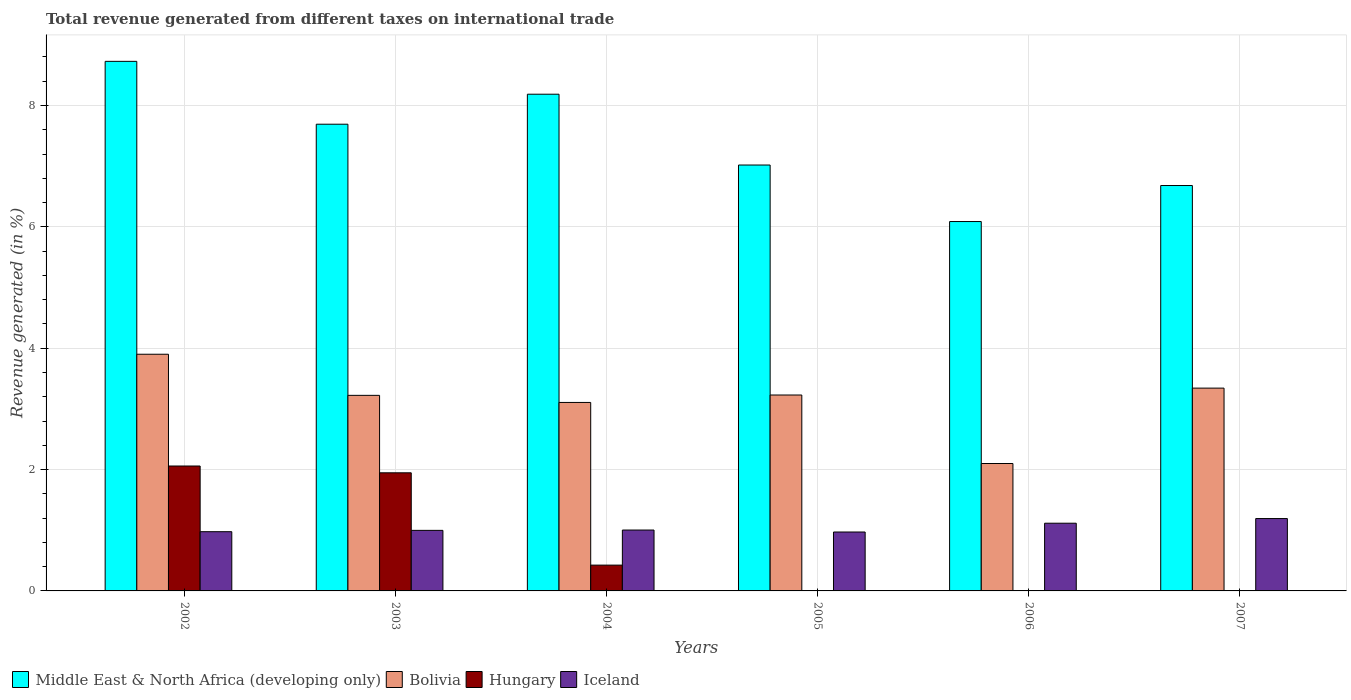How many different coloured bars are there?
Offer a very short reply. 4. Are the number of bars per tick equal to the number of legend labels?
Keep it short and to the point. No. Are the number of bars on each tick of the X-axis equal?
Make the answer very short. No. How many bars are there on the 2nd tick from the right?
Give a very brief answer. 3. What is the label of the 5th group of bars from the left?
Make the answer very short. 2006. What is the total revenue generated in Bolivia in 2004?
Your response must be concise. 3.11. Across all years, what is the maximum total revenue generated in Middle East & North Africa (developing only)?
Ensure brevity in your answer.  8.73. Across all years, what is the minimum total revenue generated in Middle East & North Africa (developing only)?
Provide a short and direct response. 6.09. What is the total total revenue generated in Middle East & North Africa (developing only) in the graph?
Ensure brevity in your answer.  44.39. What is the difference between the total revenue generated in Iceland in 2002 and that in 2004?
Provide a short and direct response. -0.03. What is the difference between the total revenue generated in Hungary in 2005 and the total revenue generated in Iceland in 2002?
Provide a succinct answer. -0.98. What is the average total revenue generated in Hungary per year?
Offer a terse response. 0.74. In the year 2003, what is the difference between the total revenue generated in Bolivia and total revenue generated in Middle East & North Africa (developing only)?
Your response must be concise. -4.47. What is the ratio of the total revenue generated in Iceland in 2003 to that in 2006?
Your answer should be very brief. 0.89. Is the total revenue generated in Middle East & North Africa (developing only) in 2003 less than that in 2005?
Provide a short and direct response. No. Is the difference between the total revenue generated in Bolivia in 2003 and 2005 greater than the difference between the total revenue generated in Middle East & North Africa (developing only) in 2003 and 2005?
Make the answer very short. No. What is the difference between the highest and the second highest total revenue generated in Hungary?
Offer a terse response. 0.11. What is the difference between the highest and the lowest total revenue generated in Middle East & North Africa (developing only)?
Your answer should be very brief. 2.64. In how many years, is the total revenue generated in Hungary greater than the average total revenue generated in Hungary taken over all years?
Provide a short and direct response. 2. Is the sum of the total revenue generated in Iceland in 2004 and 2005 greater than the maximum total revenue generated in Bolivia across all years?
Your answer should be compact. No. Is it the case that in every year, the sum of the total revenue generated in Middle East & North Africa (developing only) and total revenue generated in Bolivia is greater than the sum of total revenue generated in Hungary and total revenue generated in Iceland?
Give a very brief answer. No. Is it the case that in every year, the sum of the total revenue generated in Bolivia and total revenue generated in Middle East & North Africa (developing only) is greater than the total revenue generated in Iceland?
Your answer should be compact. Yes. Are all the bars in the graph horizontal?
Ensure brevity in your answer.  No. What is the difference between two consecutive major ticks on the Y-axis?
Your response must be concise. 2. Does the graph contain any zero values?
Your answer should be very brief. Yes. Does the graph contain grids?
Ensure brevity in your answer.  Yes. How many legend labels are there?
Keep it short and to the point. 4. What is the title of the graph?
Offer a terse response. Total revenue generated from different taxes on international trade. What is the label or title of the Y-axis?
Give a very brief answer. Revenue generated (in %). What is the Revenue generated (in %) in Middle East & North Africa (developing only) in 2002?
Give a very brief answer. 8.73. What is the Revenue generated (in %) of Bolivia in 2002?
Provide a short and direct response. 3.9. What is the Revenue generated (in %) in Hungary in 2002?
Offer a very short reply. 2.06. What is the Revenue generated (in %) in Iceland in 2002?
Provide a succinct answer. 0.98. What is the Revenue generated (in %) in Middle East & North Africa (developing only) in 2003?
Provide a short and direct response. 7.69. What is the Revenue generated (in %) in Bolivia in 2003?
Your response must be concise. 3.22. What is the Revenue generated (in %) in Hungary in 2003?
Your answer should be very brief. 1.95. What is the Revenue generated (in %) of Iceland in 2003?
Ensure brevity in your answer.  1. What is the Revenue generated (in %) in Middle East & North Africa (developing only) in 2004?
Make the answer very short. 8.19. What is the Revenue generated (in %) of Bolivia in 2004?
Provide a short and direct response. 3.11. What is the Revenue generated (in %) of Hungary in 2004?
Your answer should be very brief. 0.43. What is the Revenue generated (in %) of Iceland in 2004?
Offer a very short reply. 1. What is the Revenue generated (in %) of Middle East & North Africa (developing only) in 2005?
Your answer should be very brief. 7.02. What is the Revenue generated (in %) in Bolivia in 2005?
Offer a very short reply. 3.23. What is the Revenue generated (in %) of Iceland in 2005?
Ensure brevity in your answer.  0.97. What is the Revenue generated (in %) in Middle East & North Africa (developing only) in 2006?
Provide a succinct answer. 6.09. What is the Revenue generated (in %) in Bolivia in 2006?
Make the answer very short. 2.1. What is the Revenue generated (in %) of Iceland in 2006?
Keep it short and to the point. 1.12. What is the Revenue generated (in %) in Middle East & North Africa (developing only) in 2007?
Provide a short and direct response. 6.68. What is the Revenue generated (in %) in Bolivia in 2007?
Your response must be concise. 3.34. What is the Revenue generated (in %) in Hungary in 2007?
Offer a very short reply. 0. What is the Revenue generated (in %) of Iceland in 2007?
Your answer should be compact. 1.19. Across all years, what is the maximum Revenue generated (in %) of Middle East & North Africa (developing only)?
Provide a short and direct response. 8.73. Across all years, what is the maximum Revenue generated (in %) of Bolivia?
Provide a short and direct response. 3.9. Across all years, what is the maximum Revenue generated (in %) in Hungary?
Offer a very short reply. 2.06. Across all years, what is the maximum Revenue generated (in %) in Iceland?
Keep it short and to the point. 1.19. Across all years, what is the minimum Revenue generated (in %) in Middle East & North Africa (developing only)?
Make the answer very short. 6.09. Across all years, what is the minimum Revenue generated (in %) in Bolivia?
Give a very brief answer. 2.1. Across all years, what is the minimum Revenue generated (in %) in Iceland?
Keep it short and to the point. 0.97. What is the total Revenue generated (in %) of Middle East & North Africa (developing only) in the graph?
Provide a succinct answer. 44.39. What is the total Revenue generated (in %) in Bolivia in the graph?
Provide a succinct answer. 18.9. What is the total Revenue generated (in %) of Hungary in the graph?
Your answer should be very brief. 4.43. What is the total Revenue generated (in %) of Iceland in the graph?
Offer a terse response. 6.26. What is the difference between the Revenue generated (in %) in Middle East & North Africa (developing only) in 2002 and that in 2003?
Your answer should be very brief. 1.04. What is the difference between the Revenue generated (in %) of Bolivia in 2002 and that in 2003?
Your response must be concise. 0.68. What is the difference between the Revenue generated (in %) of Hungary in 2002 and that in 2003?
Give a very brief answer. 0.11. What is the difference between the Revenue generated (in %) of Iceland in 2002 and that in 2003?
Offer a very short reply. -0.02. What is the difference between the Revenue generated (in %) in Middle East & North Africa (developing only) in 2002 and that in 2004?
Your response must be concise. 0.54. What is the difference between the Revenue generated (in %) in Bolivia in 2002 and that in 2004?
Provide a short and direct response. 0.79. What is the difference between the Revenue generated (in %) of Hungary in 2002 and that in 2004?
Offer a terse response. 1.63. What is the difference between the Revenue generated (in %) of Iceland in 2002 and that in 2004?
Provide a succinct answer. -0.03. What is the difference between the Revenue generated (in %) of Middle East & North Africa (developing only) in 2002 and that in 2005?
Provide a succinct answer. 1.71. What is the difference between the Revenue generated (in %) of Bolivia in 2002 and that in 2005?
Keep it short and to the point. 0.67. What is the difference between the Revenue generated (in %) in Iceland in 2002 and that in 2005?
Your answer should be very brief. 0.01. What is the difference between the Revenue generated (in %) of Middle East & North Africa (developing only) in 2002 and that in 2006?
Offer a terse response. 2.64. What is the difference between the Revenue generated (in %) of Bolivia in 2002 and that in 2006?
Provide a short and direct response. 1.8. What is the difference between the Revenue generated (in %) in Iceland in 2002 and that in 2006?
Provide a succinct answer. -0.14. What is the difference between the Revenue generated (in %) of Middle East & North Africa (developing only) in 2002 and that in 2007?
Your answer should be compact. 2.05. What is the difference between the Revenue generated (in %) in Bolivia in 2002 and that in 2007?
Give a very brief answer. 0.56. What is the difference between the Revenue generated (in %) of Iceland in 2002 and that in 2007?
Provide a short and direct response. -0.22. What is the difference between the Revenue generated (in %) of Middle East & North Africa (developing only) in 2003 and that in 2004?
Your response must be concise. -0.49. What is the difference between the Revenue generated (in %) in Bolivia in 2003 and that in 2004?
Make the answer very short. 0.12. What is the difference between the Revenue generated (in %) of Hungary in 2003 and that in 2004?
Keep it short and to the point. 1.52. What is the difference between the Revenue generated (in %) of Iceland in 2003 and that in 2004?
Provide a short and direct response. -0.01. What is the difference between the Revenue generated (in %) of Middle East & North Africa (developing only) in 2003 and that in 2005?
Offer a terse response. 0.67. What is the difference between the Revenue generated (in %) of Bolivia in 2003 and that in 2005?
Offer a terse response. -0.01. What is the difference between the Revenue generated (in %) of Iceland in 2003 and that in 2005?
Offer a terse response. 0.03. What is the difference between the Revenue generated (in %) of Middle East & North Africa (developing only) in 2003 and that in 2006?
Keep it short and to the point. 1.6. What is the difference between the Revenue generated (in %) in Bolivia in 2003 and that in 2006?
Offer a very short reply. 1.12. What is the difference between the Revenue generated (in %) of Iceland in 2003 and that in 2006?
Ensure brevity in your answer.  -0.12. What is the difference between the Revenue generated (in %) of Middle East & North Africa (developing only) in 2003 and that in 2007?
Make the answer very short. 1.01. What is the difference between the Revenue generated (in %) in Bolivia in 2003 and that in 2007?
Your answer should be compact. -0.12. What is the difference between the Revenue generated (in %) in Iceland in 2003 and that in 2007?
Provide a short and direct response. -0.19. What is the difference between the Revenue generated (in %) in Middle East & North Africa (developing only) in 2004 and that in 2005?
Your answer should be very brief. 1.17. What is the difference between the Revenue generated (in %) of Bolivia in 2004 and that in 2005?
Keep it short and to the point. -0.12. What is the difference between the Revenue generated (in %) in Iceland in 2004 and that in 2005?
Provide a succinct answer. 0.03. What is the difference between the Revenue generated (in %) of Middle East & North Africa (developing only) in 2004 and that in 2006?
Your answer should be very brief. 2.1. What is the difference between the Revenue generated (in %) in Bolivia in 2004 and that in 2006?
Offer a very short reply. 1.01. What is the difference between the Revenue generated (in %) of Iceland in 2004 and that in 2006?
Provide a short and direct response. -0.11. What is the difference between the Revenue generated (in %) in Middle East & North Africa (developing only) in 2004 and that in 2007?
Make the answer very short. 1.5. What is the difference between the Revenue generated (in %) in Bolivia in 2004 and that in 2007?
Give a very brief answer. -0.24. What is the difference between the Revenue generated (in %) in Iceland in 2004 and that in 2007?
Your answer should be very brief. -0.19. What is the difference between the Revenue generated (in %) of Middle East & North Africa (developing only) in 2005 and that in 2006?
Offer a terse response. 0.93. What is the difference between the Revenue generated (in %) of Bolivia in 2005 and that in 2006?
Give a very brief answer. 1.13. What is the difference between the Revenue generated (in %) of Iceland in 2005 and that in 2006?
Ensure brevity in your answer.  -0.14. What is the difference between the Revenue generated (in %) in Middle East & North Africa (developing only) in 2005 and that in 2007?
Give a very brief answer. 0.34. What is the difference between the Revenue generated (in %) of Bolivia in 2005 and that in 2007?
Make the answer very short. -0.11. What is the difference between the Revenue generated (in %) in Iceland in 2005 and that in 2007?
Your answer should be compact. -0.22. What is the difference between the Revenue generated (in %) in Middle East & North Africa (developing only) in 2006 and that in 2007?
Your answer should be compact. -0.59. What is the difference between the Revenue generated (in %) of Bolivia in 2006 and that in 2007?
Offer a terse response. -1.24. What is the difference between the Revenue generated (in %) in Iceland in 2006 and that in 2007?
Offer a very short reply. -0.08. What is the difference between the Revenue generated (in %) in Middle East & North Africa (developing only) in 2002 and the Revenue generated (in %) in Bolivia in 2003?
Offer a terse response. 5.5. What is the difference between the Revenue generated (in %) in Middle East & North Africa (developing only) in 2002 and the Revenue generated (in %) in Hungary in 2003?
Your response must be concise. 6.78. What is the difference between the Revenue generated (in %) of Middle East & North Africa (developing only) in 2002 and the Revenue generated (in %) of Iceland in 2003?
Offer a very short reply. 7.73. What is the difference between the Revenue generated (in %) of Bolivia in 2002 and the Revenue generated (in %) of Hungary in 2003?
Ensure brevity in your answer.  1.95. What is the difference between the Revenue generated (in %) in Bolivia in 2002 and the Revenue generated (in %) in Iceland in 2003?
Your answer should be very brief. 2.9. What is the difference between the Revenue generated (in %) in Hungary in 2002 and the Revenue generated (in %) in Iceland in 2003?
Your answer should be very brief. 1.06. What is the difference between the Revenue generated (in %) of Middle East & North Africa (developing only) in 2002 and the Revenue generated (in %) of Bolivia in 2004?
Keep it short and to the point. 5.62. What is the difference between the Revenue generated (in %) in Middle East & North Africa (developing only) in 2002 and the Revenue generated (in %) in Hungary in 2004?
Provide a short and direct response. 8.3. What is the difference between the Revenue generated (in %) in Middle East & North Africa (developing only) in 2002 and the Revenue generated (in %) in Iceland in 2004?
Make the answer very short. 7.72. What is the difference between the Revenue generated (in %) in Bolivia in 2002 and the Revenue generated (in %) in Hungary in 2004?
Provide a short and direct response. 3.48. What is the difference between the Revenue generated (in %) of Bolivia in 2002 and the Revenue generated (in %) of Iceland in 2004?
Your answer should be very brief. 2.9. What is the difference between the Revenue generated (in %) in Hungary in 2002 and the Revenue generated (in %) in Iceland in 2004?
Give a very brief answer. 1.06. What is the difference between the Revenue generated (in %) of Middle East & North Africa (developing only) in 2002 and the Revenue generated (in %) of Bolivia in 2005?
Provide a succinct answer. 5.5. What is the difference between the Revenue generated (in %) in Middle East & North Africa (developing only) in 2002 and the Revenue generated (in %) in Iceland in 2005?
Keep it short and to the point. 7.76. What is the difference between the Revenue generated (in %) in Bolivia in 2002 and the Revenue generated (in %) in Iceland in 2005?
Give a very brief answer. 2.93. What is the difference between the Revenue generated (in %) of Hungary in 2002 and the Revenue generated (in %) of Iceland in 2005?
Ensure brevity in your answer.  1.09. What is the difference between the Revenue generated (in %) in Middle East & North Africa (developing only) in 2002 and the Revenue generated (in %) in Bolivia in 2006?
Your answer should be very brief. 6.63. What is the difference between the Revenue generated (in %) in Middle East & North Africa (developing only) in 2002 and the Revenue generated (in %) in Iceland in 2006?
Your answer should be compact. 7.61. What is the difference between the Revenue generated (in %) in Bolivia in 2002 and the Revenue generated (in %) in Iceland in 2006?
Your answer should be very brief. 2.78. What is the difference between the Revenue generated (in %) in Hungary in 2002 and the Revenue generated (in %) in Iceland in 2006?
Keep it short and to the point. 0.94. What is the difference between the Revenue generated (in %) in Middle East & North Africa (developing only) in 2002 and the Revenue generated (in %) in Bolivia in 2007?
Keep it short and to the point. 5.39. What is the difference between the Revenue generated (in %) in Middle East & North Africa (developing only) in 2002 and the Revenue generated (in %) in Iceland in 2007?
Ensure brevity in your answer.  7.53. What is the difference between the Revenue generated (in %) in Bolivia in 2002 and the Revenue generated (in %) in Iceland in 2007?
Your response must be concise. 2.71. What is the difference between the Revenue generated (in %) in Hungary in 2002 and the Revenue generated (in %) in Iceland in 2007?
Offer a very short reply. 0.87. What is the difference between the Revenue generated (in %) of Middle East & North Africa (developing only) in 2003 and the Revenue generated (in %) of Bolivia in 2004?
Provide a succinct answer. 4.59. What is the difference between the Revenue generated (in %) in Middle East & North Africa (developing only) in 2003 and the Revenue generated (in %) in Hungary in 2004?
Your answer should be very brief. 7.27. What is the difference between the Revenue generated (in %) of Middle East & North Africa (developing only) in 2003 and the Revenue generated (in %) of Iceland in 2004?
Ensure brevity in your answer.  6.69. What is the difference between the Revenue generated (in %) in Bolivia in 2003 and the Revenue generated (in %) in Hungary in 2004?
Offer a terse response. 2.8. What is the difference between the Revenue generated (in %) in Bolivia in 2003 and the Revenue generated (in %) in Iceland in 2004?
Keep it short and to the point. 2.22. What is the difference between the Revenue generated (in %) of Hungary in 2003 and the Revenue generated (in %) of Iceland in 2004?
Your answer should be compact. 0.94. What is the difference between the Revenue generated (in %) of Middle East & North Africa (developing only) in 2003 and the Revenue generated (in %) of Bolivia in 2005?
Provide a succinct answer. 4.46. What is the difference between the Revenue generated (in %) in Middle East & North Africa (developing only) in 2003 and the Revenue generated (in %) in Iceland in 2005?
Your answer should be very brief. 6.72. What is the difference between the Revenue generated (in %) in Bolivia in 2003 and the Revenue generated (in %) in Iceland in 2005?
Keep it short and to the point. 2.25. What is the difference between the Revenue generated (in %) in Hungary in 2003 and the Revenue generated (in %) in Iceland in 2005?
Give a very brief answer. 0.98. What is the difference between the Revenue generated (in %) in Middle East & North Africa (developing only) in 2003 and the Revenue generated (in %) in Bolivia in 2006?
Provide a short and direct response. 5.59. What is the difference between the Revenue generated (in %) of Middle East & North Africa (developing only) in 2003 and the Revenue generated (in %) of Iceland in 2006?
Give a very brief answer. 6.58. What is the difference between the Revenue generated (in %) of Bolivia in 2003 and the Revenue generated (in %) of Iceland in 2006?
Ensure brevity in your answer.  2.11. What is the difference between the Revenue generated (in %) in Hungary in 2003 and the Revenue generated (in %) in Iceland in 2006?
Offer a very short reply. 0.83. What is the difference between the Revenue generated (in %) of Middle East & North Africa (developing only) in 2003 and the Revenue generated (in %) of Bolivia in 2007?
Provide a succinct answer. 4.35. What is the difference between the Revenue generated (in %) in Middle East & North Africa (developing only) in 2003 and the Revenue generated (in %) in Iceland in 2007?
Your answer should be compact. 6.5. What is the difference between the Revenue generated (in %) in Bolivia in 2003 and the Revenue generated (in %) in Iceland in 2007?
Your answer should be very brief. 2.03. What is the difference between the Revenue generated (in %) of Hungary in 2003 and the Revenue generated (in %) of Iceland in 2007?
Make the answer very short. 0.75. What is the difference between the Revenue generated (in %) in Middle East & North Africa (developing only) in 2004 and the Revenue generated (in %) in Bolivia in 2005?
Make the answer very short. 4.96. What is the difference between the Revenue generated (in %) of Middle East & North Africa (developing only) in 2004 and the Revenue generated (in %) of Iceland in 2005?
Offer a terse response. 7.22. What is the difference between the Revenue generated (in %) in Bolivia in 2004 and the Revenue generated (in %) in Iceland in 2005?
Give a very brief answer. 2.14. What is the difference between the Revenue generated (in %) in Hungary in 2004 and the Revenue generated (in %) in Iceland in 2005?
Provide a short and direct response. -0.55. What is the difference between the Revenue generated (in %) of Middle East & North Africa (developing only) in 2004 and the Revenue generated (in %) of Bolivia in 2006?
Offer a terse response. 6.09. What is the difference between the Revenue generated (in %) of Middle East & North Africa (developing only) in 2004 and the Revenue generated (in %) of Iceland in 2006?
Offer a terse response. 7.07. What is the difference between the Revenue generated (in %) of Bolivia in 2004 and the Revenue generated (in %) of Iceland in 2006?
Offer a very short reply. 1.99. What is the difference between the Revenue generated (in %) in Hungary in 2004 and the Revenue generated (in %) in Iceland in 2006?
Provide a succinct answer. -0.69. What is the difference between the Revenue generated (in %) of Middle East & North Africa (developing only) in 2004 and the Revenue generated (in %) of Bolivia in 2007?
Keep it short and to the point. 4.84. What is the difference between the Revenue generated (in %) of Middle East & North Africa (developing only) in 2004 and the Revenue generated (in %) of Iceland in 2007?
Make the answer very short. 6.99. What is the difference between the Revenue generated (in %) of Bolivia in 2004 and the Revenue generated (in %) of Iceland in 2007?
Your answer should be compact. 1.91. What is the difference between the Revenue generated (in %) of Hungary in 2004 and the Revenue generated (in %) of Iceland in 2007?
Keep it short and to the point. -0.77. What is the difference between the Revenue generated (in %) of Middle East & North Africa (developing only) in 2005 and the Revenue generated (in %) of Bolivia in 2006?
Provide a short and direct response. 4.92. What is the difference between the Revenue generated (in %) of Middle East & North Africa (developing only) in 2005 and the Revenue generated (in %) of Iceland in 2006?
Your answer should be very brief. 5.9. What is the difference between the Revenue generated (in %) in Bolivia in 2005 and the Revenue generated (in %) in Iceland in 2006?
Your answer should be compact. 2.11. What is the difference between the Revenue generated (in %) of Middle East & North Africa (developing only) in 2005 and the Revenue generated (in %) of Bolivia in 2007?
Offer a terse response. 3.68. What is the difference between the Revenue generated (in %) of Middle East & North Africa (developing only) in 2005 and the Revenue generated (in %) of Iceland in 2007?
Give a very brief answer. 5.83. What is the difference between the Revenue generated (in %) in Bolivia in 2005 and the Revenue generated (in %) in Iceland in 2007?
Your answer should be very brief. 2.04. What is the difference between the Revenue generated (in %) in Middle East & North Africa (developing only) in 2006 and the Revenue generated (in %) in Bolivia in 2007?
Your answer should be very brief. 2.75. What is the difference between the Revenue generated (in %) in Middle East & North Africa (developing only) in 2006 and the Revenue generated (in %) in Iceland in 2007?
Provide a short and direct response. 4.89. What is the difference between the Revenue generated (in %) in Bolivia in 2006 and the Revenue generated (in %) in Iceland in 2007?
Ensure brevity in your answer.  0.91. What is the average Revenue generated (in %) in Middle East & North Africa (developing only) per year?
Offer a terse response. 7.4. What is the average Revenue generated (in %) in Bolivia per year?
Your answer should be compact. 3.15. What is the average Revenue generated (in %) of Hungary per year?
Make the answer very short. 0.74. What is the average Revenue generated (in %) in Iceland per year?
Provide a short and direct response. 1.04. In the year 2002, what is the difference between the Revenue generated (in %) in Middle East & North Africa (developing only) and Revenue generated (in %) in Bolivia?
Make the answer very short. 4.83. In the year 2002, what is the difference between the Revenue generated (in %) in Middle East & North Africa (developing only) and Revenue generated (in %) in Hungary?
Ensure brevity in your answer.  6.67. In the year 2002, what is the difference between the Revenue generated (in %) of Middle East & North Africa (developing only) and Revenue generated (in %) of Iceland?
Your answer should be compact. 7.75. In the year 2002, what is the difference between the Revenue generated (in %) in Bolivia and Revenue generated (in %) in Hungary?
Keep it short and to the point. 1.84. In the year 2002, what is the difference between the Revenue generated (in %) in Bolivia and Revenue generated (in %) in Iceland?
Your answer should be compact. 2.92. In the year 2002, what is the difference between the Revenue generated (in %) in Hungary and Revenue generated (in %) in Iceland?
Provide a succinct answer. 1.08. In the year 2003, what is the difference between the Revenue generated (in %) in Middle East & North Africa (developing only) and Revenue generated (in %) in Bolivia?
Your answer should be compact. 4.47. In the year 2003, what is the difference between the Revenue generated (in %) of Middle East & North Africa (developing only) and Revenue generated (in %) of Hungary?
Provide a succinct answer. 5.75. In the year 2003, what is the difference between the Revenue generated (in %) in Middle East & North Africa (developing only) and Revenue generated (in %) in Iceland?
Your answer should be very brief. 6.69. In the year 2003, what is the difference between the Revenue generated (in %) of Bolivia and Revenue generated (in %) of Hungary?
Provide a succinct answer. 1.28. In the year 2003, what is the difference between the Revenue generated (in %) in Bolivia and Revenue generated (in %) in Iceland?
Offer a very short reply. 2.23. In the year 2003, what is the difference between the Revenue generated (in %) of Hungary and Revenue generated (in %) of Iceland?
Make the answer very short. 0.95. In the year 2004, what is the difference between the Revenue generated (in %) of Middle East & North Africa (developing only) and Revenue generated (in %) of Bolivia?
Your answer should be compact. 5.08. In the year 2004, what is the difference between the Revenue generated (in %) of Middle East & North Africa (developing only) and Revenue generated (in %) of Hungary?
Provide a short and direct response. 7.76. In the year 2004, what is the difference between the Revenue generated (in %) of Middle East & North Africa (developing only) and Revenue generated (in %) of Iceland?
Offer a very short reply. 7.18. In the year 2004, what is the difference between the Revenue generated (in %) in Bolivia and Revenue generated (in %) in Hungary?
Offer a terse response. 2.68. In the year 2004, what is the difference between the Revenue generated (in %) of Bolivia and Revenue generated (in %) of Iceland?
Your response must be concise. 2.1. In the year 2004, what is the difference between the Revenue generated (in %) in Hungary and Revenue generated (in %) in Iceland?
Provide a short and direct response. -0.58. In the year 2005, what is the difference between the Revenue generated (in %) of Middle East & North Africa (developing only) and Revenue generated (in %) of Bolivia?
Offer a terse response. 3.79. In the year 2005, what is the difference between the Revenue generated (in %) of Middle East & North Africa (developing only) and Revenue generated (in %) of Iceland?
Your answer should be compact. 6.05. In the year 2005, what is the difference between the Revenue generated (in %) in Bolivia and Revenue generated (in %) in Iceland?
Your response must be concise. 2.26. In the year 2006, what is the difference between the Revenue generated (in %) of Middle East & North Africa (developing only) and Revenue generated (in %) of Bolivia?
Give a very brief answer. 3.99. In the year 2006, what is the difference between the Revenue generated (in %) in Middle East & North Africa (developing only) and Revenue generated (in %) in Iceland?
Make the answer very short. 4.97. In the year 2006, what is the difference between the Revenue generated (in %) in Bolivia and Revenue generated (in %) in Iceland?
Make the answer very short. 0.98. In the year 2007, what is the difference between the Revenue generated (in %) in Middle East & North Africa (developing only) and Revenue generated (in %) in Bolivia?
Offer a terse response. 3.34. In the year 2007, what is the difference between the Revenue generated (in %) in Middle East & North Africa (developing only) and Revenue generated (in %) in Iceland?
Make the answer very short. 5.49. In the year 2007, what is the difference between the Revenue generated (in %) in Bolivia and Revenue generated (in %) in Iceland?
Ensure brevity in your answer.  2.15. What is the ratio of the Revenue generated (in %) in Middle East & North Africa (developing only) in 2002 to that in 2003?
Ensure brevity in your answer.  1.13. What is the ratio of the Revenue generated (in %) of Bolivia in 2002 to that in 2003?
Your answer should be compact. 1.21. What is the ratio of the Revenue generated (in %) in Hungary in 2002 to that in 2003?
Offer a very short reply. 1.06. What is the ratio of the Revenue generated (in %) in Iceland in 2002 to that in 2003?
Offer a very short reply. 0.98. What is the ratio of the Revenue generated (in %) of Middle East & North Africa (developing only) in 2002 to that in 2004?
Ensure brevity in your answer.  1.07. What is the ratio of the Revenue generated (in %) in Bolivia in 2002 to that in 2004?
Ensure brevity in your answer.  1.26. What is the ratio of the Revenue generated (in %) of Hungary in 2002 to that in 2004?
Make the answer very short. 4.84. What is the ratio of the Revenue generated (in %) in Iceland in 2002 to that in 2004?
Provide a short and direct response. 0.97. What is the ratio of the Revenue generated (in %) in Middle East & North Africa (developing only) in 2002 to that in 2005?
Make the answer very short. 1.24. What is the ratio of the Revenue generated (in %) of Bolivia in 2002 to that in 2005?
Your answer should be very brief. 1.21. What is the ratio of the Revenue generated (in %) of Iceland in 2002 to that in 2005?
Offer a very short reply. 1.01. What is the ratio of the Revenue generated (in %) of Middle East & North Africa (developing only) in 2002 to that in 2006?
Keep it short and to the point. 1.43. What is the ratio of the Revenue generated (in %) in Bolivia in 2002 to that in 2006?
Make the answer very short. 1.86. What is the ratio of the Revenue generated (in %) of Iceland in 2002 to that in 2006?
Your answer should be very brief. 0.87. What is the ratio of the Revenue generated (in %) in Middle East & North Africa (developing only) in 2002 to that in 2007?
Make the answer very short. 1.31. What is the ratio of the Revenue generated (in %) in Bolivia in 2002 to that in 2007?
Your answer should be very brief. 1.17. What is the ratio of the Revenue generated (in %) of Iceland in 2002 to that in 2007?
Offer a terse response. 0.82. What is the ratio of the Revenue generated (in %) in Middle East & North Africa (developing only) in 2003 to that in 2004?
Offer a very short reply. 0.94. What is the ratio of the Revenue generated (in %) of Bolivia in 2003 to that in 2004?
Offer a terse response. 1.04. What is the ratio of the Revenue generated (in %) in Hungary in 2003 to that in 2004?
Your response must be concise. 4.58. What is the ratio of the Revenue generated (in %) of Iceland in 2003 to that in 2004?
Keep it short and to the point. 0.99. What is the ratio of the Revenue generated (in %) in Middle East & North Africa (developing only) in 2003 to that in 2005?
Offer a very short reply. 1.1. What is the ratio of the Revenue generated (in %) of Iceland in 2003 to that in 2005?
Offer a very short reply. 1.03. What is the ratio of the Revenue generated (in %) in Middle East & North Africa (developing only) in 2003 to that in 2006?
Keep it short and to the point. 1.26. What is the ratio of the Revenue generated (in %) of Bolivia in 2003 to that in 2006?
Your answer should be very brief. 1.53. What is the ratio of the Revenue generated (in %) in Iceland in 2003 to that in 2006?
Your response must be concise. 0.89. What is the ratio of the Revenue generated (in %) of Middle East & North Africa (developing only) in 2003 to that in 2007?
Keep it short and to the point. 1.15. What is the ratio of the Revenue generated (in %) of Bolivia in 2003 to that in 2007?
Ensure brevity in your answer.  0.96. What is the ratio of the Revenue generated (in %) in Iceland in 2003 to that in 2007?
Give a very brief answer. 0.84. What is the ratio of the Revenue generated (in %) of Middle East & North Africa (developing only) in 2004 to that in 2005?
Make the answer very short. 1.17. What is the ratio of the Revenue generated (in %) of Iceland in 2004 to that in 2005?
Ensure brevity in your answer.  1.03. What is the ratio of the Revenue generated (in %) in Middle East & North Africa (developing only) in 2004 to that in 2006?
Your response must be concise. 1.34. What is the ratio of the Revenue generated (in %) in Bolivia in 2004 to that in 2006?
Offer a terse response. 1.48. What is the ratio of the Revenue generated (in %) in Iceland in 2004 to that in 2006?
Provide a succinct answer. 0.9. What is the ratio of the Revenue generated (in %) in Middle East & North Africa (developing only) in 2004 to that in 2007?
Offer a very short reply. 1.23. What is the ratio of the Revenue generated (in %) of Bolivia in 2004 to that in 2007?
Give a very brief answer. 0.93. What is the ratio of the Revenue generated (in %) in Iceland in 2004 to that in 2007?
Ensure brevity in your answer.  0.84. What is the ratio of the Revenue generated (in %) in Middle East & North Africa (developing only) in 2005 to that in 2006?
Your answer should be very brief. 1.15. What is the ratio of the Revenue generated (in %) of Bolivia in 2005 to that in 2006?
Ensure brevity in your answer.  1.54. What is the ratio of the Revenue generated (in %) in Iceland in 2005 to that in 2006?
Make the answer very short. 0.87. What is the ratio of the Revenue generated (in %) in Middle East & North Africa (developing only) in 2005 to that in 2007?
Ensure brevity in your answer.  1.05. What is the ratio of the Revenue generated (in %) of Bolivia in 2005 to that in 2007?
Your answer should be very brief. 0.97. What is the ratio of the Revenue generated (in %) of Iceland in 2005 to that in 2007?
Make the answer very short. 0.81. What is the ratio of the Revenue generated (in %) in Middle East & North Africa (developing only) in 2006 to that in 2007?
Your answer should be compact. 0.91. What is the ratio of the Revenue generated (in %) of Bolivia in 2006 to that in 2007?
Your response must be concise. 0.63. What is the ratio of the Revenue generated (in %) in Iceland in 2006 to that in 2007?
Your answer should be very brief. 0.94. What is the difference between the highest and the second highest Revenue generated (in %) in Middle East & North Africa (developing only)?
Offer a terse response. 0.54. What is the difference between the highest and the second highest Revenue generated (in %) of Bolivia?
Provide a succinct answer. 0.56. What is the difference between the highest and the second highest Revenue generated (in %) in Hungary?
Make the answer very short. 0.11. What is the difference between the highest and the second highest Revenue generated (in %) in Iceland?
Keep it short and to the point. 0.08. What is the difference between the highest and the lowest Revenue generated (in %) of Middle East & North Africa (developing only)?
Offer a very short reply. 2.64. What is the difference between the highest and the lowest Revenue generated (in %) of Bolivia?
Your answer should be very brief. 1.8. What is the difference between the highest and the lowest Revenue generated (in %) of Hungary?
Offer a very short reply. 2.06. What is the difference between the highest and the lowest Revenue generated (in %) of Iceland?
Provide a short and direct response. 0.22. 